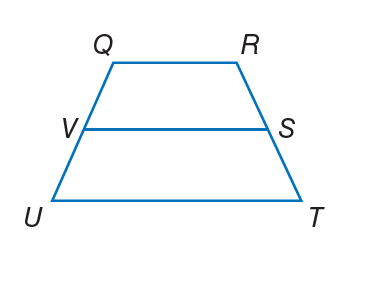Answer the mathemtical geometry problem and directly provide the correct option letter.
Question: For trapezoid Q R T U, V and S are midpoints of the legs. If Q R = 12 and U T = 22, find V S.
Choices: A: 5 B: 12 C: 17 D: 22 C 